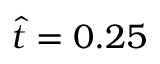Convert formula to latex. <formula><loc_0><loc_0><loc_500><loc_500>\hat { t } = 0 . 2 5</formula> 